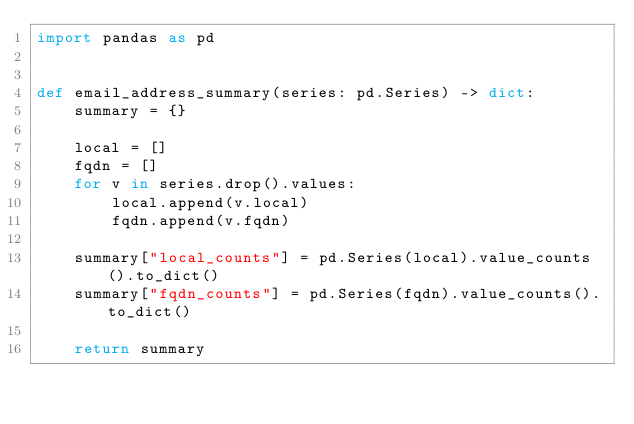<code> <loc_0><loc_0><loc_500><loc_500><_Python_>import pandas as pd


def email_address_summary(series: pd.Series) -> dict:
    summary = {}

    local = []
    fqdn = []
    for v in series.drop().values:
        local.append(v.local)
        fqdn.append(v.fqdn)

    summary["local_counts"] = pd.Series(local).value_counts().to_dict()
    summary["fqdn_counts"] = pd.Series(fqdn).value_counts().to_dict()

    return summary
</code> 